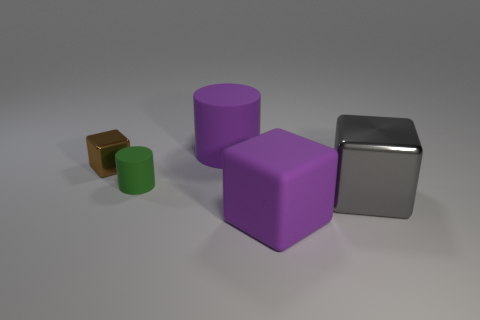Add 5 green blocks. How many objects exist? 10 Subtract all cubes. How many objects are left? 2 Add 4 rubber cylinders. How many rubber cylinders are left? 6 Add 1 big brown blocks. How many big brown blocks exist? 1 Subtract 0 blue spheres. How many objects are left? 5 Subtract all large rubber objects. Subtract all green rubber things. How many objects are left? 2 